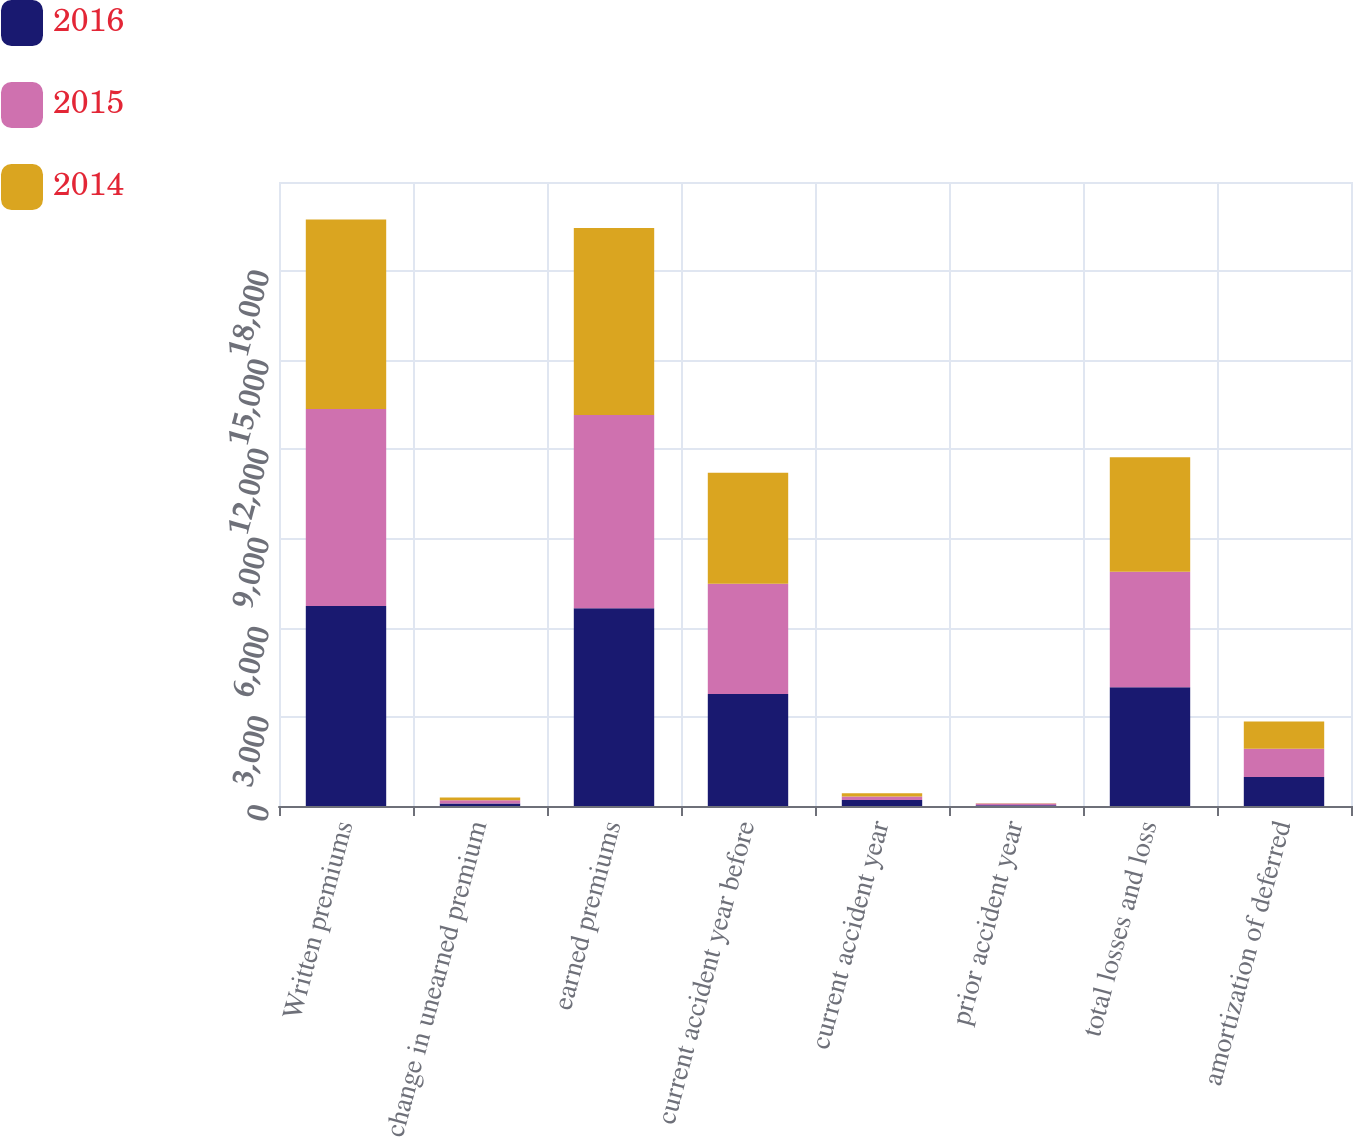Convert chart to OTSL. <chart><loc_0><loc_0><loc_500><loc_500><stacked_bar_chart><ecel><fcel>Written premiums<fcel>change in unearned premium<fcel>earned premiums<fcel>current accident year before<fcel>current accident year<fcel>prior accident year<fcel>total losses and loss<fcel>amortization of deferred<nl><fcel>2016<fcel>6732<fcel>81<fcel>6651<fcel>3766<fcel>200<fcel>28<fcel>3994<fcel>973<nl><fcel>2015<fcel>6625<fcel>114<fcel>6511<fcel>3712<fcel>121<fcel>53<fcel>3886<fcel>951<nl><fcel>2014<fcel>6381<fcel>92<fcel>6289<fcel>3733<fcel>109<fcel>13<fcel>3855<fcel>919<nl></chart> 